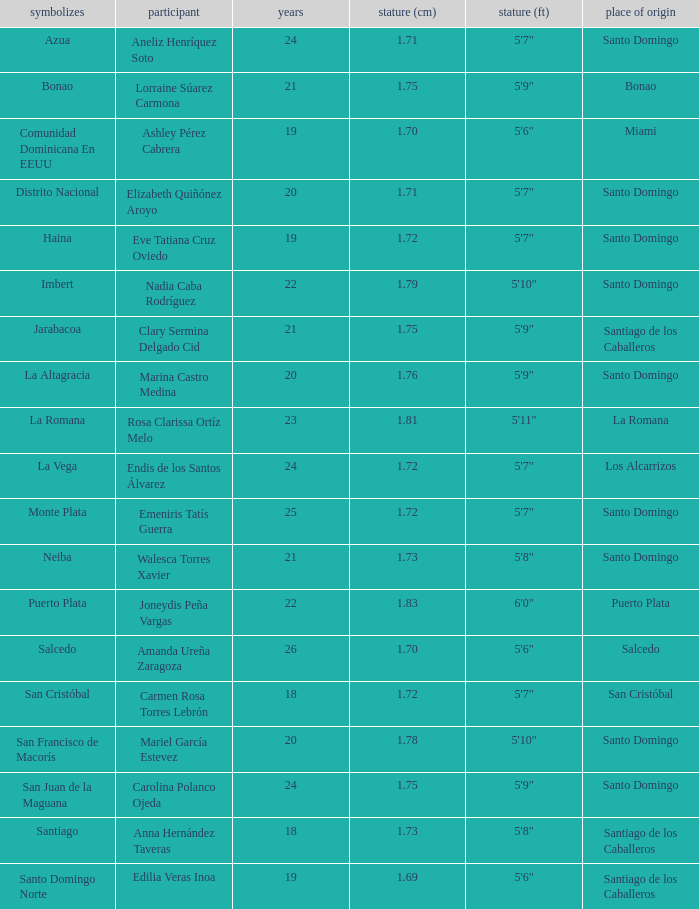Name the represents for los alcarrizos La Vega. 